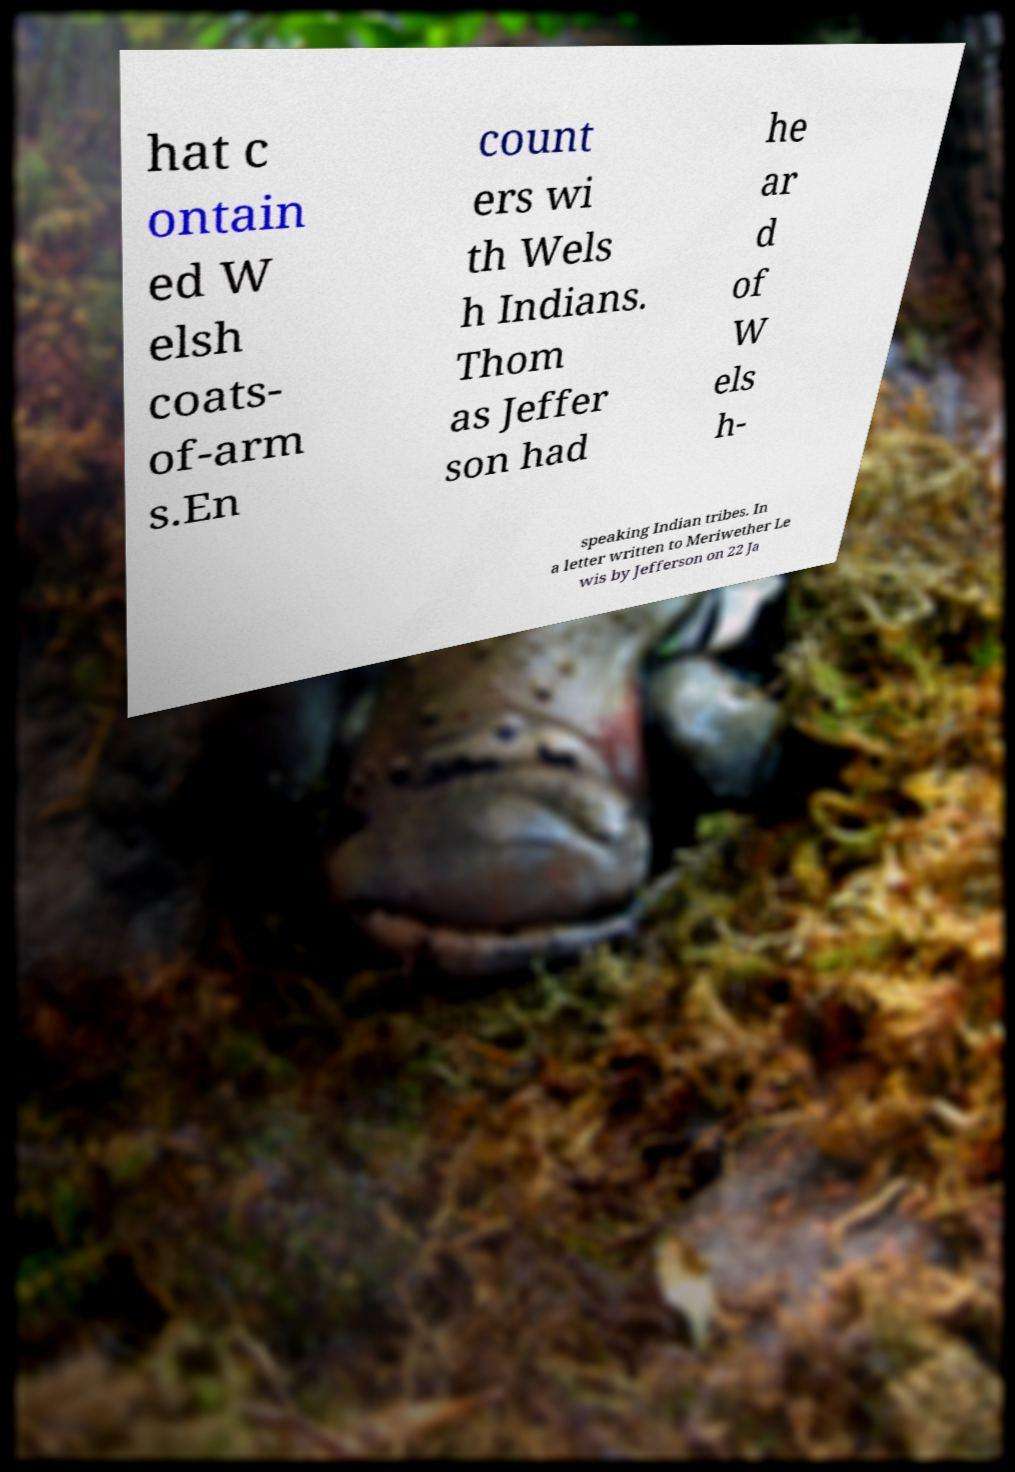Could you extract and type out the text from this image? hat c ontain ed W elsh coats- of-arm s.En count ers wi th Wels h Indians. Thom as Jeffer son had he ar d of W els h- speaking Indian tribes. In a letter written to Meriwether Le wis by Jefferson on 22 Ja 